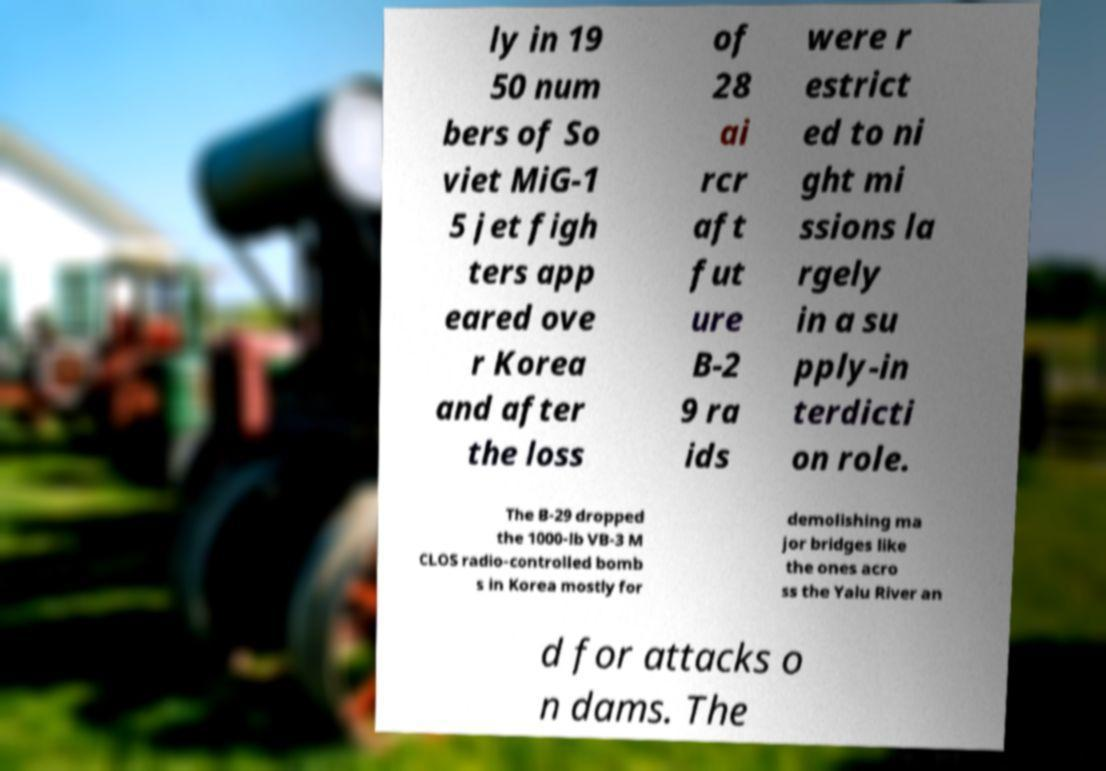Please identify and transcribe the text found in this image. ly in 19 50 num bers of So viet MiG-1 5 jet figh ters app eared ove r Korea and after the loss of 28 ai rcr aft fut ure B-2 9 ra ids were r estrict ed to ni ght mi ssions la rgely in a su pply-in terdicti on role. The B-29 dropped the 1000-lb VB-3 M CLOS radio-controlled bomb s in Korea mostly for demolishing ma jor bridges like the ones acro ss the Yalu River an d for attacks o n dams. The 